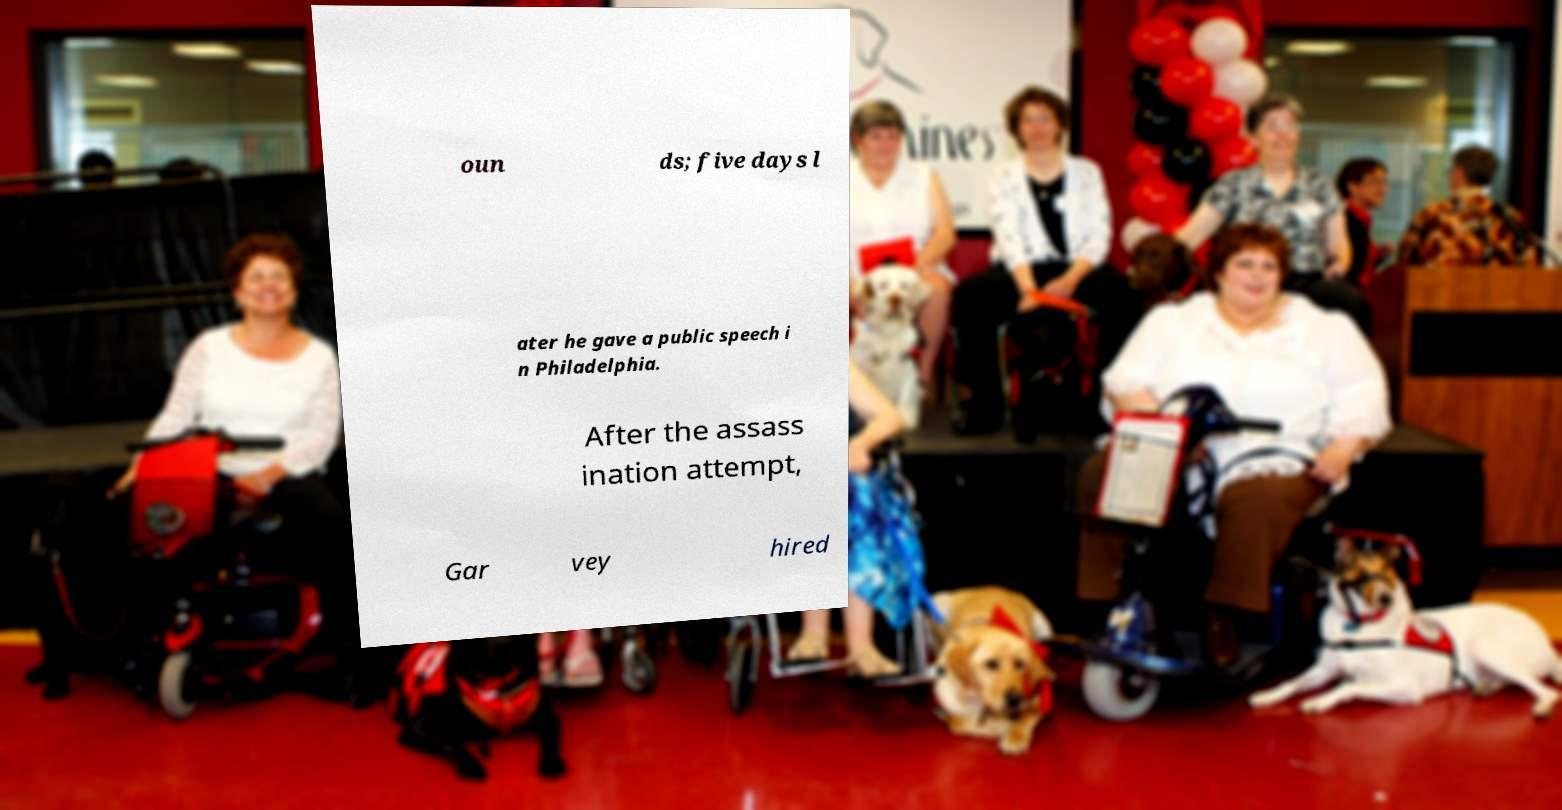Can you accurately transcribe the text from the provided image for me? oun ds; five days l ater he gave a public speech i n Philadelphia. After the assass ination attempt, Gar vey hired 